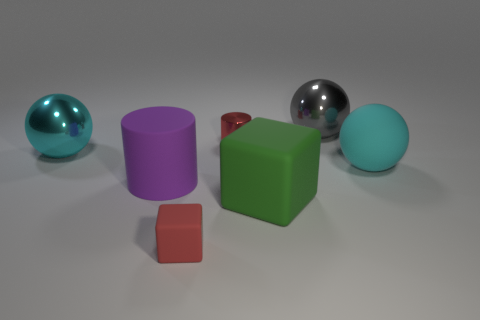What is the material of the gray thing?
Make the answer very short. Metal. There is a small object that is the same color as the metallic cylinder; what material is it?
Provide a short and direct response. Rubber. What number of other objects are there of the same material as the green object?
Your answer should be very brief. 3. There is a red metal object; does it have the same shape as the big matte object left of the large green rubber block?
Make the answer very short. Yes. How many objects are small purple matte cylinders or cyan objects?
Provide a succinct answer. 2. What number of other objects are there of the same color as the tiny metal thing?
Offer a terse response. 1. What is the shape of the other red thing that is the same size as the red matte object?
Your answer should be compact. Cylinder. What is the color of the cube that is behind the tiny matte cube?
Offer a terse response. Green. What number of objects are either shiny things that are behind the small red metal object or big cyan spheres to the right of the large purple cylinder?
Provide a short and direct response. 2. Is the size of the cyan matte sphere the same as the gray metallic sphere?
Offer a very short reply. Yes. 